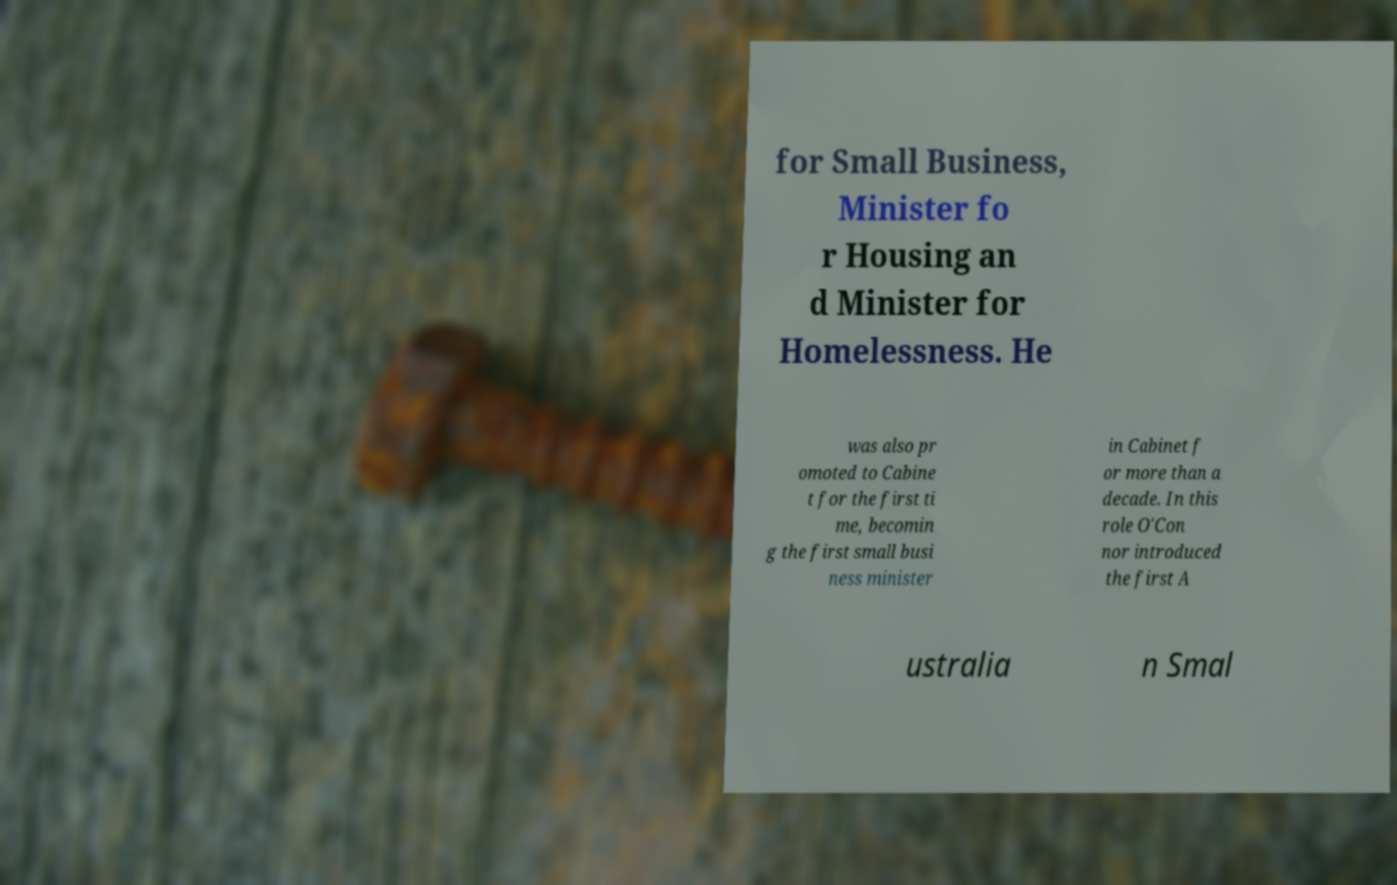I need the written content from this picture converted into text. Can you do that? for Small Business, Minister fo r Housing an d Minister for Homelessness. He was also pr omoted to Cabine t for the first ti me, becomin g the first small busi ness minister in Cabinet f or more than a decade. In this role O'Con nor introduced the first A ustralia n Smal 